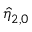<formula> <loc_0><loc_0><loc_500><loc_500>\hat { \eta } _ { 2 , 0 }</formula> 